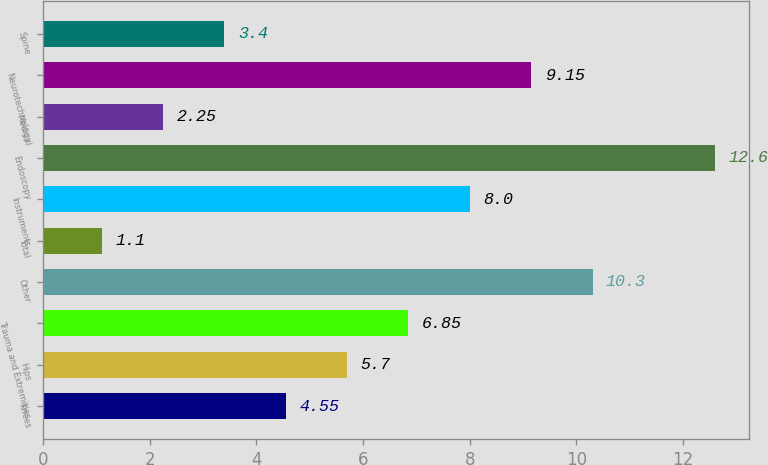Convert chart. <chart><loc_0><loc_0><loc_500><loc_500><bar_chart><fcel>Knees<fcel>Hips<fcel>Trauma and Extremities<fcel>Other<fcel>Total<fcel>Instruments<fcel>Endoscopy<fcel>Medical<fcel>Neurotechnology<fcel>Spine<nl><fcel>4.55<fcel>5.7<fcel>6.85<fcel>10.3<fcel>1.1<fcel>8<fcel>12.6<fcel>2.25<fcel>9.15<fcel>3.4<nl></chart> 